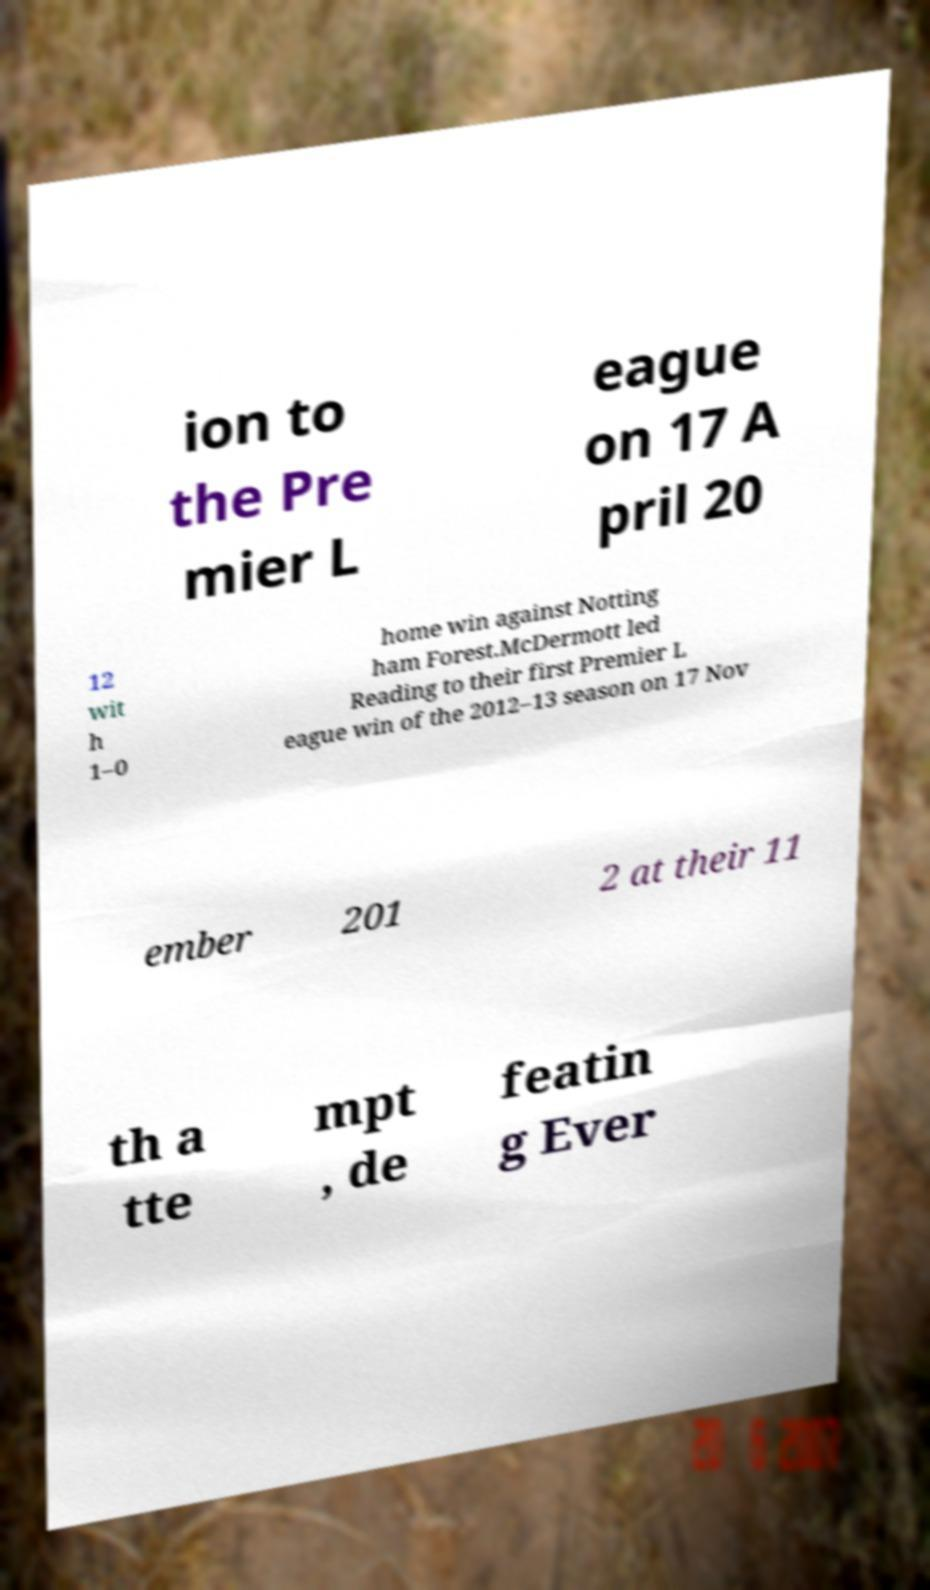What messages or text are displayed in this image? I need them in a readable, typed format. ion to the Pre mier L eague on 17 A pril 20 12 wit h 1–0 home win against Notting ham Forest.McDermott led Reading to their first Premier L eague win of the 2012–13 season on 17 Nov ember 201 2 at their 11 th a tte mpt , de featin g Ever 